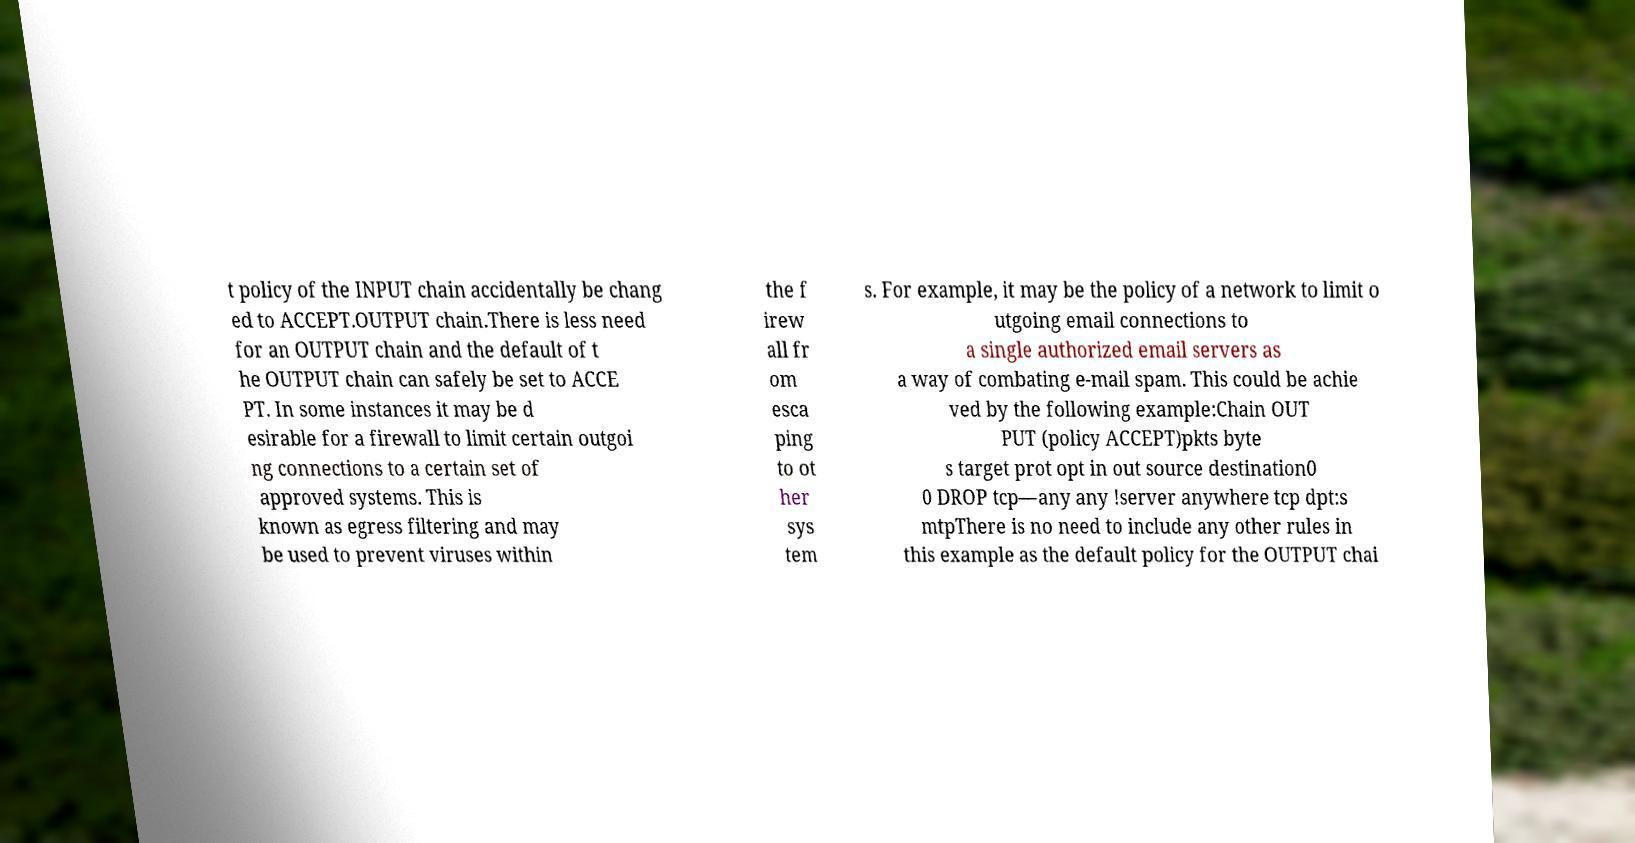What messages or text are displayed in this image? I need them in a readable, typed format. t policy of the INPUT chain accidentally be chang ed to ACCEPT.OUTPUT chain.There is less need for an OUTPUT chain and the default of t he OUTPUT chain can safely be set to ACCE PT. In some instances it may be d esirable for a firewall to limit certain outgoi ng connections to a certain set of approved systems. This is known as egress filtering and may be used to prevent viruses within the f irew all fr om esca ping to ot her sys tem s. For example, it may be the policy of a network to limit o utgoing email connections to a single authorized email servers as a way of combating e-mail spam. This could be achie ved by the following example:Chain OUT PUT (policy ACCEPT)pkts byte s target prot opt in out source destination0 0 DROP tcp—any any !server anywhere tcp dpt:s mtpThere is no need to include any other rules in this example as the default policy for the OUTPUT chai 